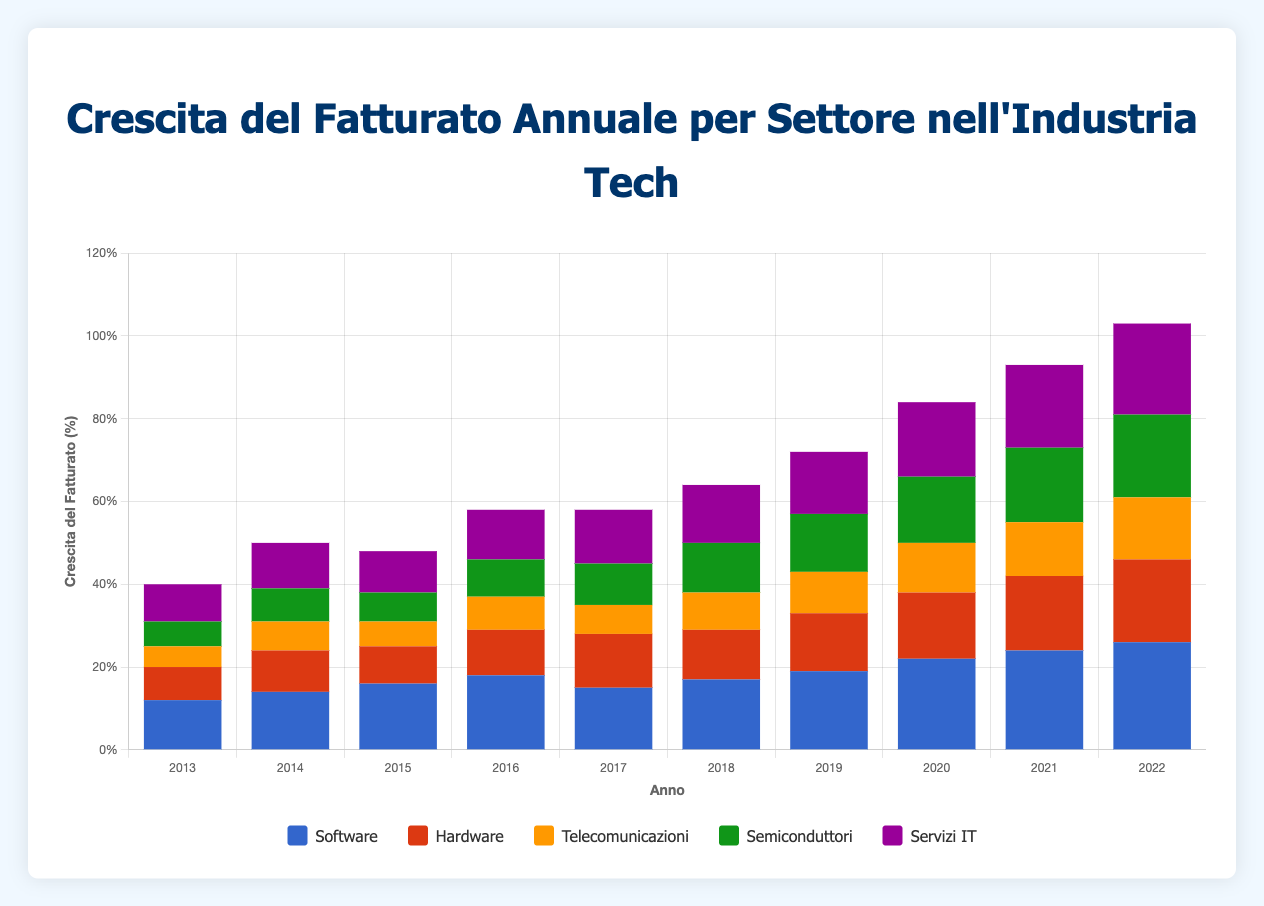What's the average annual revenue growth for the Telecommunications sector over the decade? Sum all the annual revenue growth percentages for the Telecommunications sector (5 + 7 + 6 + 8 + 7 + 9 + 10 + 12 + 13 + 15 = 92), then divide by the number of years (10). The average is 92 / 10 = 9.2%
Answer: 9.2% Which sector had the highest revenue growth in 2020? Look at the revenue growth data for each sector in 2020: Software (22%), Hardware (16%), Telecommunications (12%), Semiconductors (16%), IT Services (18%). The Software sector has the highest growth at 22%.
Answer: Software What was the total revenue growth for the IT Services sector in years 2018 and 2019 combined? Add the revenue growth percentages for IT Services in 2018 and 2019 (14% + 15% = 29%). The total growth over these two years is 29%.
Answer: 29% Which sector saw the least revenue growth in 2015? Compare the revenue growth percentages across all sectors in 2015: Software (16%), Hardware (9%), Telecommunications (6%), Semiconductors (7%), IT Services (10%). The Telecommunications sector saw the least growth at 6%.
Answer: Telecommunications By how much did the revenue growth of the Hardware sector increase from 2013 to 2022? Subtract the revenue growth of the Hardware sector in 2013 from that in 2022 (20% - 8% = 12%). The revenue growth increased by 12 percentage points.
Answer: 12% During which year did the Semiconductors sector surpass a 10% revenue growth? Identify the first year in which the revenue growth of Semiconductors was greater than 10%. This occurred in 2017 with a growth of 10%, but was more than 10% in 2018 at 12%. So, the year is 2018.
Answer: 2018 Which sector showed a consistent increase in revenue growth every year from 2013 to 2022? Look for a sector whose annual revenue growth increases year over year without any drop. IT Services sector (9, 11, 10, 12, 13, 14, 15, 18, 20, 22) shows consistent growth every year.
Answer: IT Services How did the revenue growth for the Software sector in 2022 compare to its revenue growth in 2013? Compare the values of software revenue growth for 2013 and 2022: 26% (2022) vs. 12% (2013). The revenue growth for Software in 2022 is more than double that of 2013.
Answer: More than double 